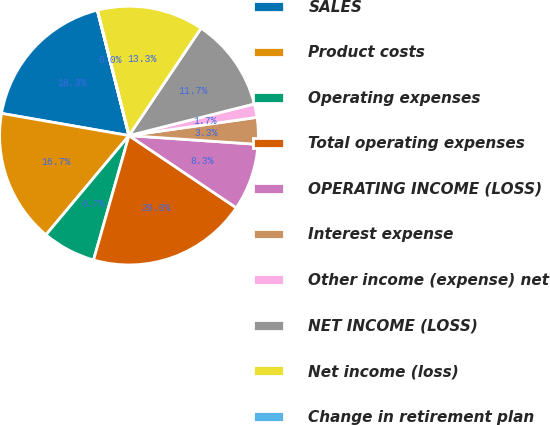Convert chart to OTSL. <chart><loc_0><loc_0><loc_500><loc_500><pie_chart><fcel>SALES<fcel>Product costs<fcel>Operating expenses<fcel>Total operating expenses<fcel>OPERATING INCOME (LOSS)<fcel>Interest expense<fcel>Other income (expense) net<fcel>NET INCOME (LOSS)<fcel>Net income (loss)<fcel>Change in retirement plan<nl><fcel>18.32%<fcel>16.66%<fcel>6.67%<fcel>19.99%<fcel>8.34%<fcel>3.34%<fcel>1.68%<fcel>11.66%<fcel>13.33%<fcel>0.01%<nl></chart> 